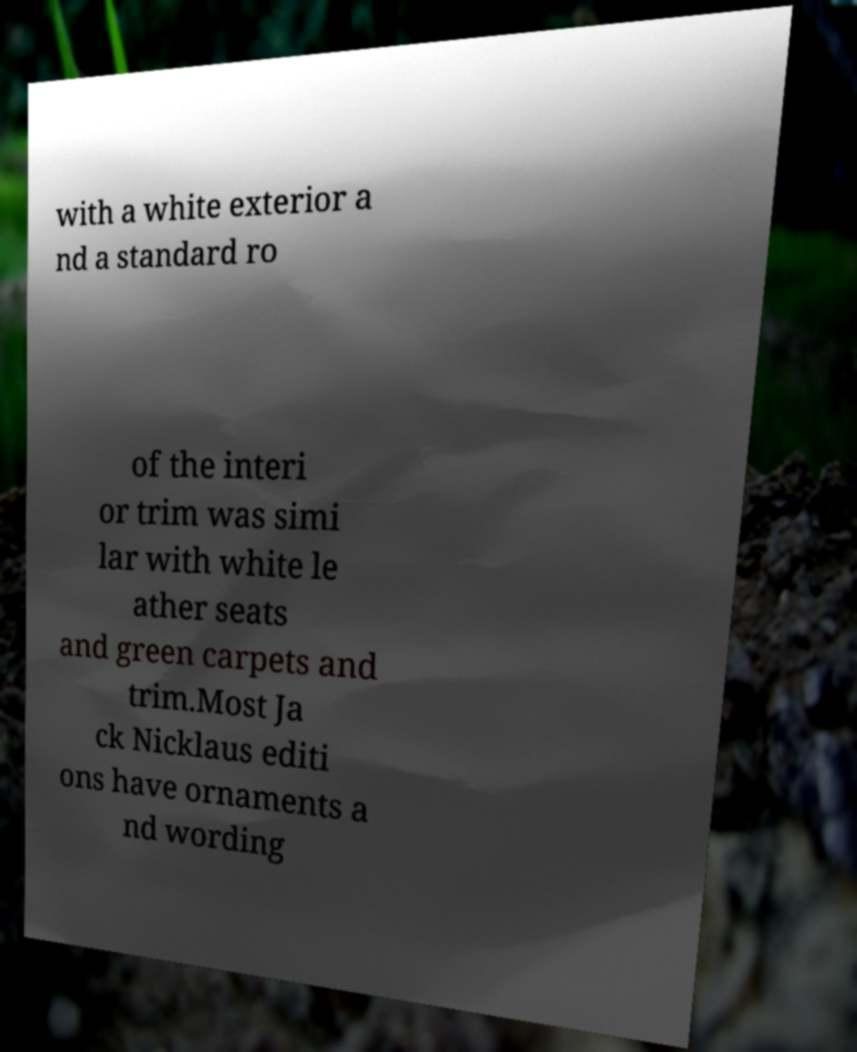Could you extract and type out the text from this image? with a white exterior a nd a standard ro of the interi or trim was simi lar with white le ather seats and green carpets and trim.Most Ja ck Nicklaus editi ons have ornaments a nd wording 